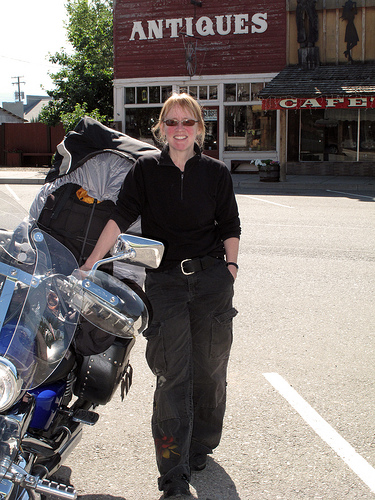<image>
Can you confirm if the lady is on the hotel? No. The lady is not positioned on the hotel. They may be near each other, but the lady is not supported by or resting on top of the hotel. 